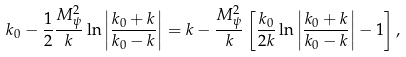Convert formula to latex. <formula><loc_0><loc_0><loc_500><loc_500>k _ { 0 } - \frac { 1 } { 2 } \frac { M _ { \psi } ^ { 2 } } { k } \ln \left | \frac { k _ { 0 } + k } { k _ { 0 } - k } \right | = k - \frac { M _ { \psi } ^ { 2 } } { k } \left [ \frac { k _ { 0 } } { 2 k } \ln \left | \frac { k _ { 0 } + k } { k _ { 0 } - k } \right | - 1 \right ] ,</formula> 